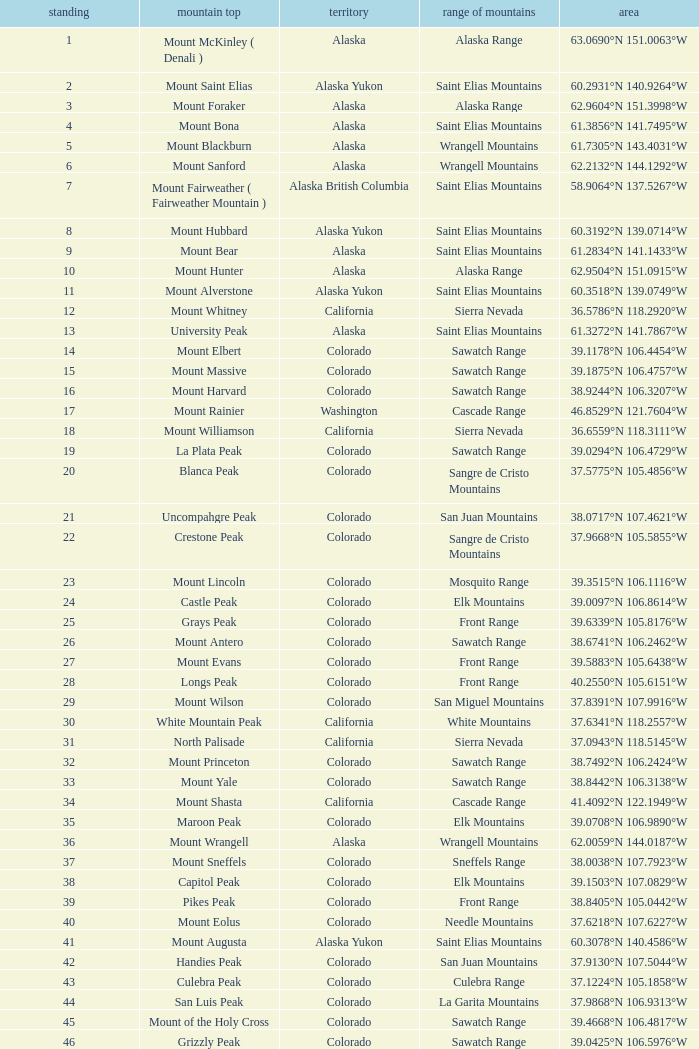What is the mountain peak when the location is 37.5775°n 105.4856°w? Blanca Peak. 